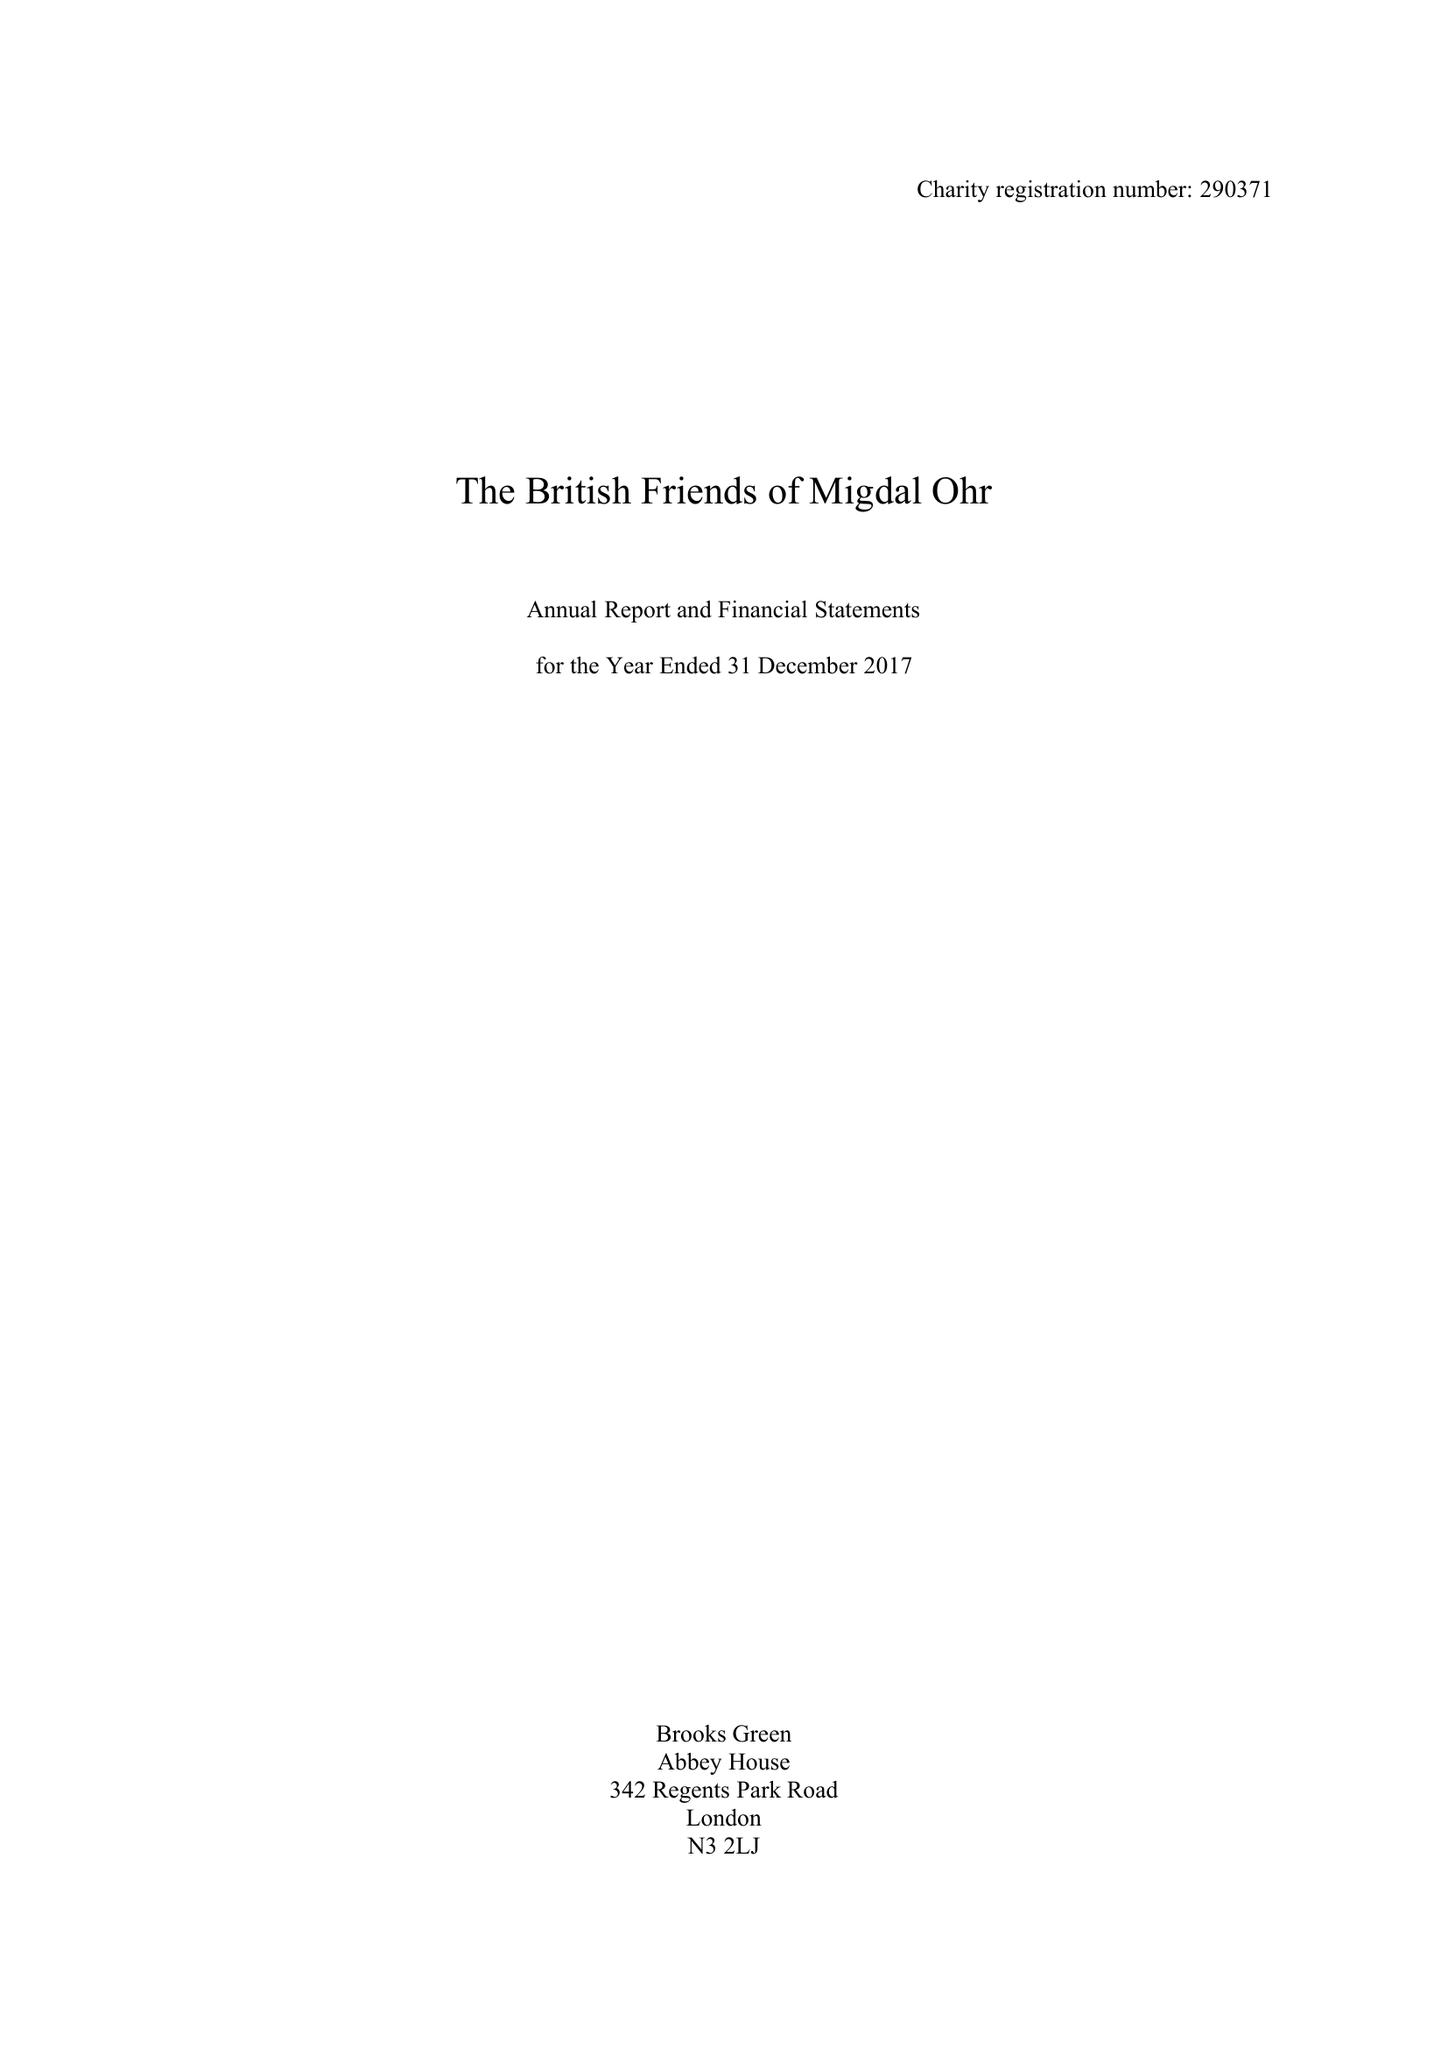What is the value for the spending_annually_in_british_pounds?
Answer the question using a single word or phrase. 424255.00 